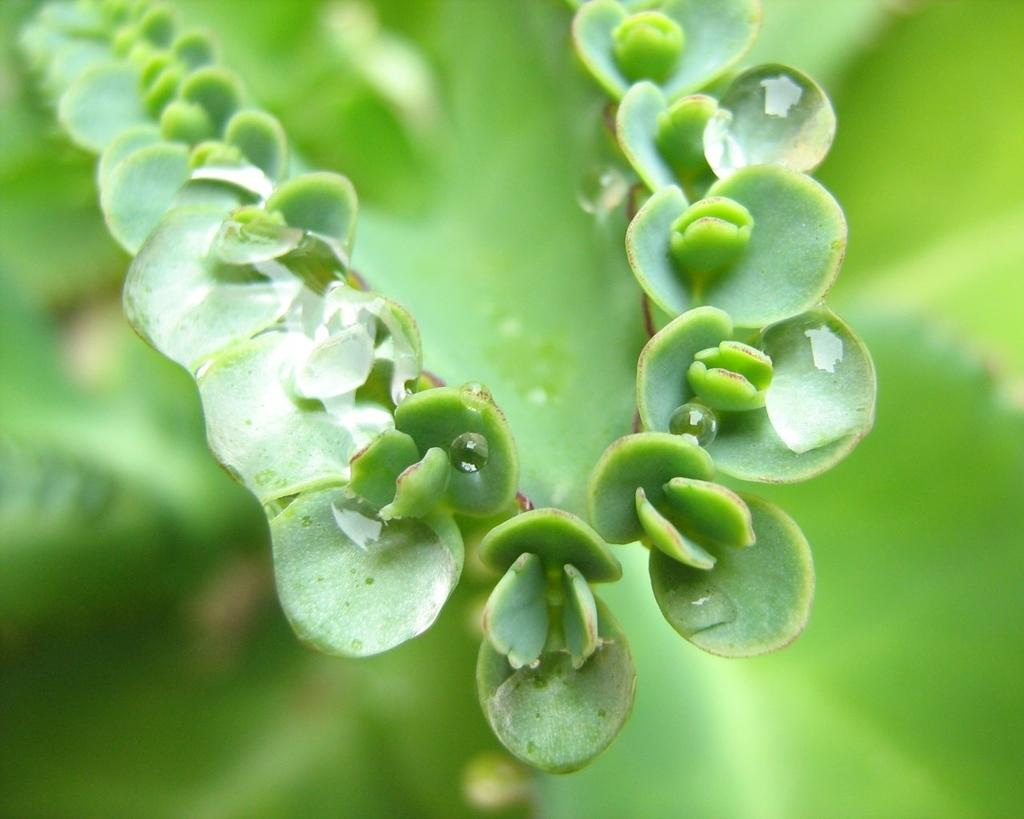What type of vegetation is present in the image? There is a plant or a tree in the image. Can you describe the condition of the plant? The plant has droplets of water on it. What is the color of the background in the image? The background of the image is green in color. How is the background of the image depicted? The image is blurred in the background. Can you see any wrens nesting in the cave behind the plant in the image? There is no cave or wrens present in the image; it features a plant or tree with water droplets and a green background. 